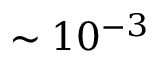<formula> <loc_0><loc_0><loc_500><loc_500>\sim 1 0 ^ { - 3 }</formula> 